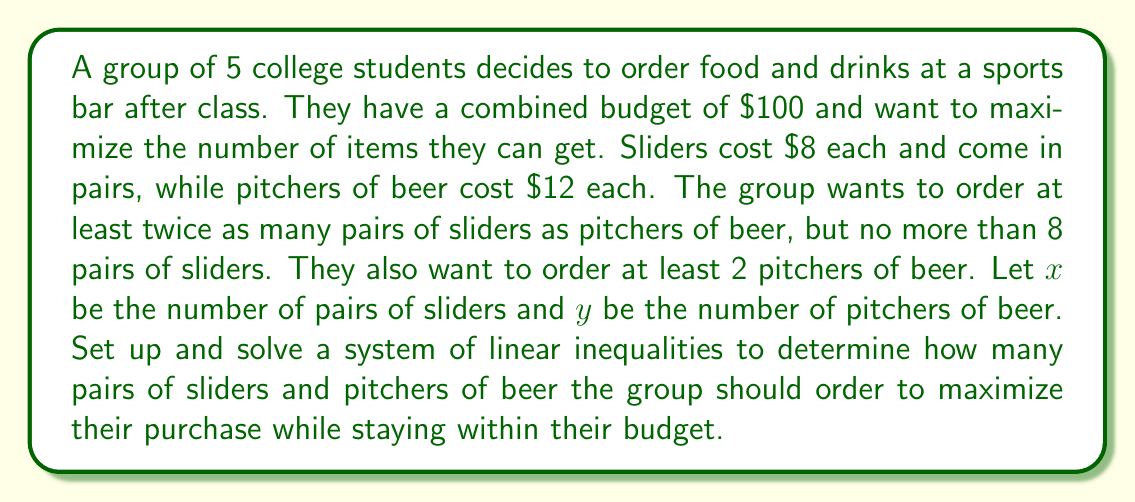Provide a solution to this math problem. Let's approach this problem step by step:

1) First, let's set up our system of inequalities based on the given information:

   Budget constraint: $8x + 12y \leq 100$
   Slider-to-beer ratio: $x \geq 2y$
   Maximum sliders: $x \leq 8$
   Minimum beer: $y \geq 2$

2) We can graph these inequalities to find the feasible region:

   [asy]
   import graph;
   size(200);
   xaxis("x (pairs of sliders)", 0, 10, Arrow);
   yaxis("y (pitchers of beer)", 0, 10, Arrow);
   
   draw((0,8.33)--(12.5,0), blue);
   draw((0,0)--(10,5), red);
   draw((8,0)--(8,10), green);
   draw((0,2)--(10,2), purple);
   
   fill((2,2)--(4,2)--(8,2)--(8,4)--(4,4)--(2,2), gray(0.7));
   
   label("$8x+12y=100$", (11,1), blue);
   label("$x=2y$", (9,5), red);
   label("$x=8$", (8.5,5), green);
   label("$y=2$", (5,2.5), purple);
   [/asy]

3) The feasible region is the shaded area. To maximize the number of items, we need to find the point in this region with the largest $x + y$ value.

4) The possible corner points of our feasible region are:
   (2, 2), (4, 2), (8, 2), and (8, 4)

5) Let's evaluate $x + y$ at each point:
   (2, 2): 2 + 2 = 4
   (4, 2): 4 + 2 = 6
   (8, 2): 8 + 2 = 10
   (8, 4): 8 + 4 = 12

6) The maximum value is 12, occurring at the point (8, 4).

Therefore, to maximize their purchase, the group should order 8 pairs of sliders and 4 pitchers of beer.

7) Let's verify that this solution satisfies all constraints:
   Budget: $8(8) + 12(4) = 64 + 48 = 112$ (This exceeds the budget, so we need to adjust)
   Slider-to-beer ratio: 8 ≥ 2(4), which is true
   Maximum sliders: 8 ≤ 8, which is true
   Minimum beer: 4 ≥ 2, which is true

8) Since the budget constraint is violated, we need to find the point on the budget line closest to (8, 4). We can solve:
   $8x + 12y = 100$
   $8(8) + 12y = 100$
   $64 + 12y = 100$
   $12y = 36$
   $y = 3$

So, the final optimal solution is (8, 3).
Answer: The group should order 8 pairs of sliders $(x = 8)$ and 3 pitchers of beer $(y = 3)$ to maximize their purchase while staying within their $100 budget. 